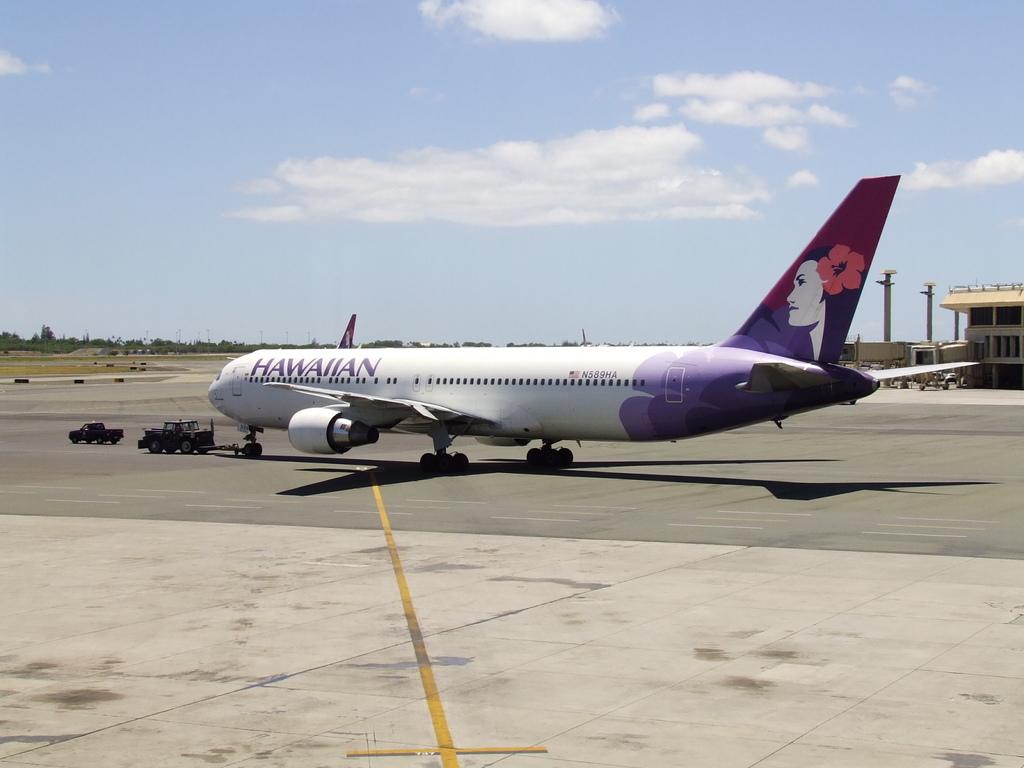What is the number painted on the plane?
Your answer should be compact. N589ha. What airline is this?
Provide a short and direct response. Hawaiian. 